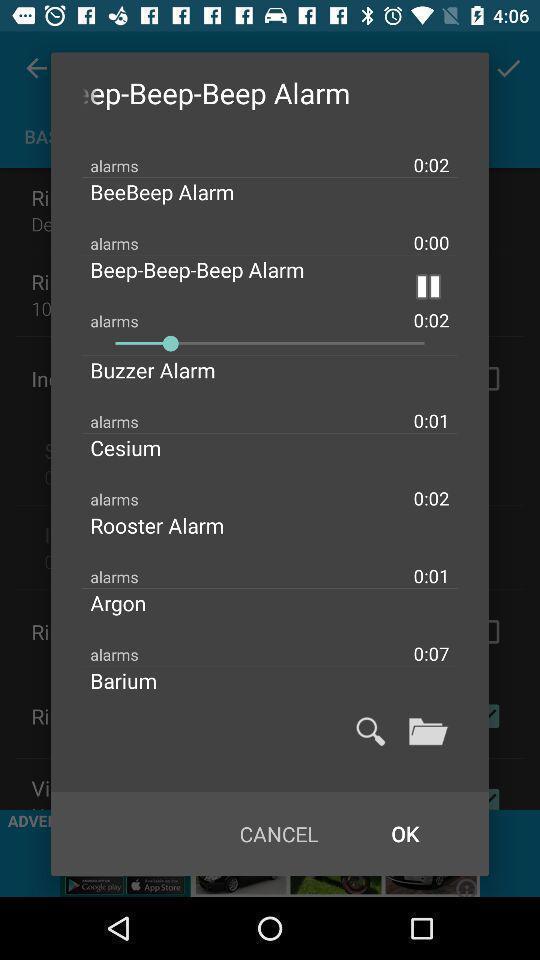What is the overall content of this screenshot? Pop-up shows alarm list in a clock app. 